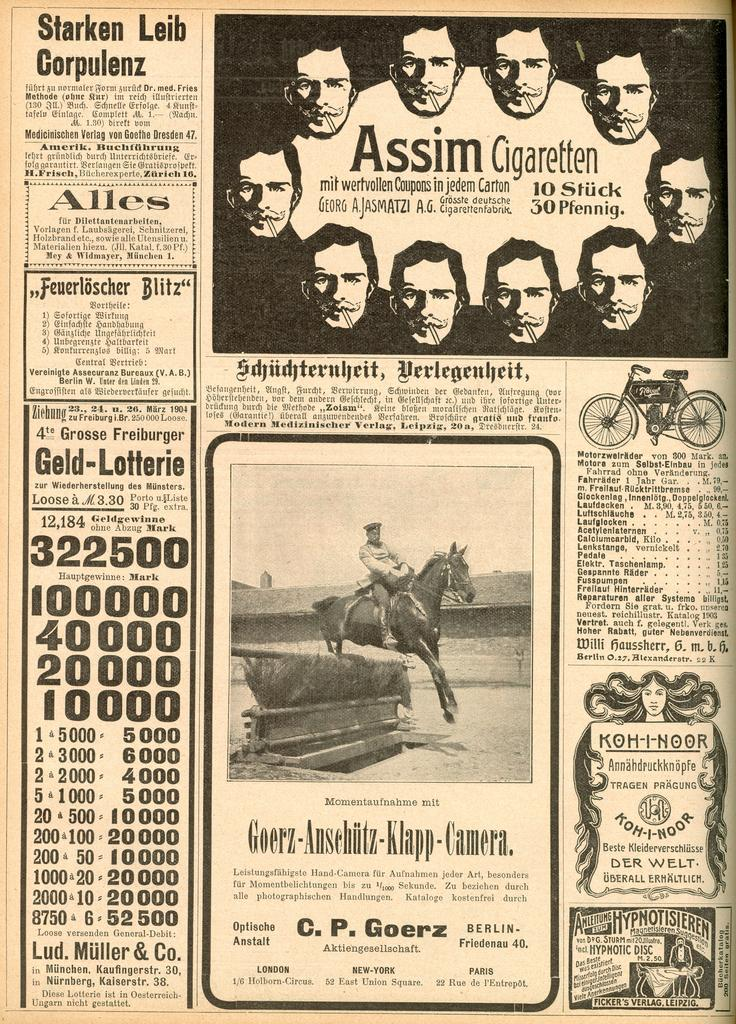What is present on the paper in the image? The paper contains text. Who or what can be seen in the image besides the paper? There are people, a horse, and a bicycle in the image. What is the opinion of the building in the image? There is no building present in the image, so it is not possible to determine its opinion. 